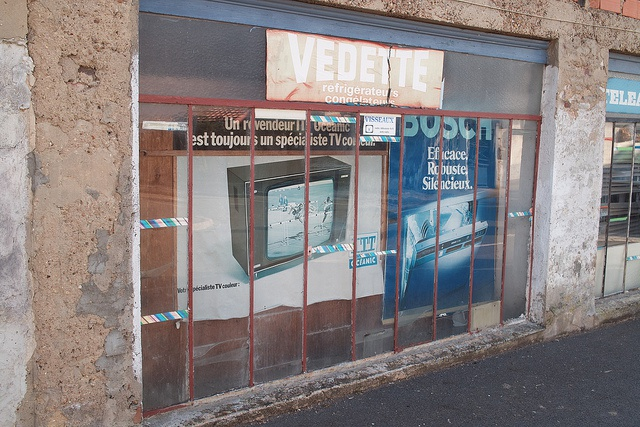Describe the objects in this image and their specific colors. I can see a tv in tan, gray, darkgray, and lightgray tones in this image. 